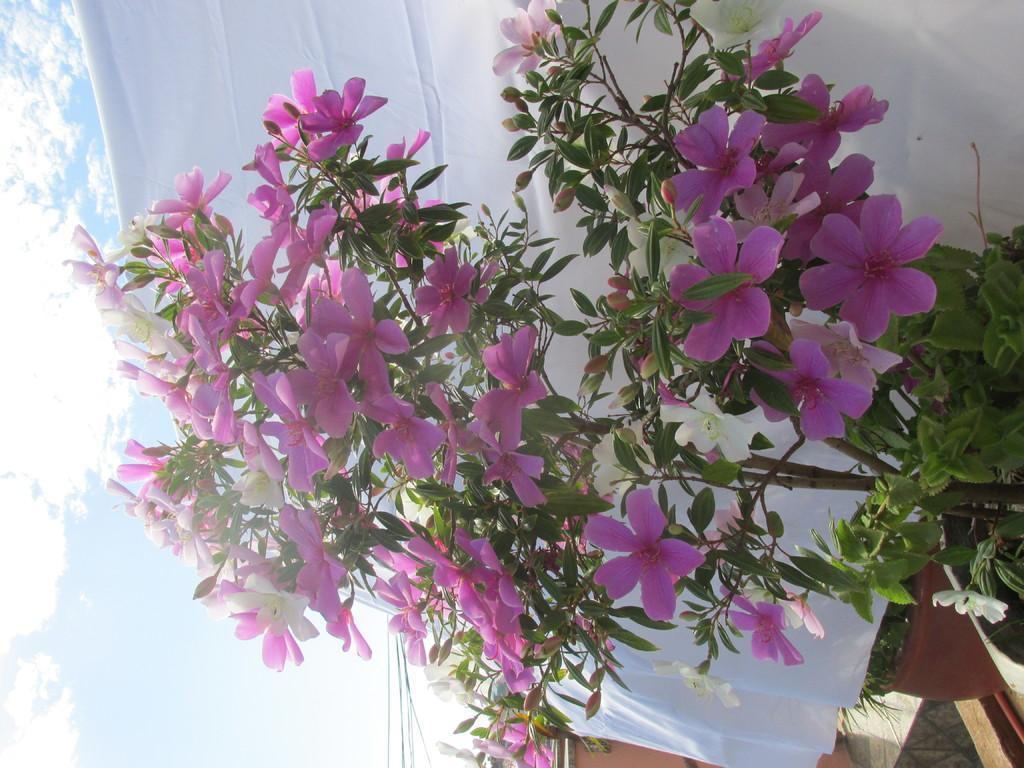Please provide a concise description of this image. This is a tilted image, in this image on the left side there is a sky, on the right side there is a plant, for that plant there are flowers, in the background there is a white curtain. 